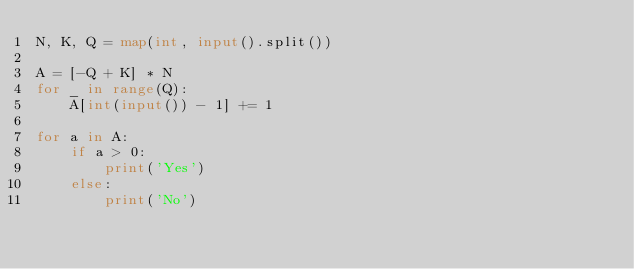Convert code to text. <code><loc_0><loc_0><loc_500><loc_500><_Python_>N, K, Q = map(int, input().split())

A = [-Q + K] * N
for _ in range(Q):
    A[int(input()) - 1] += 1

for a in A:
    if a > 0:
        print('Yes')
    else:
        print('No')
</code> 